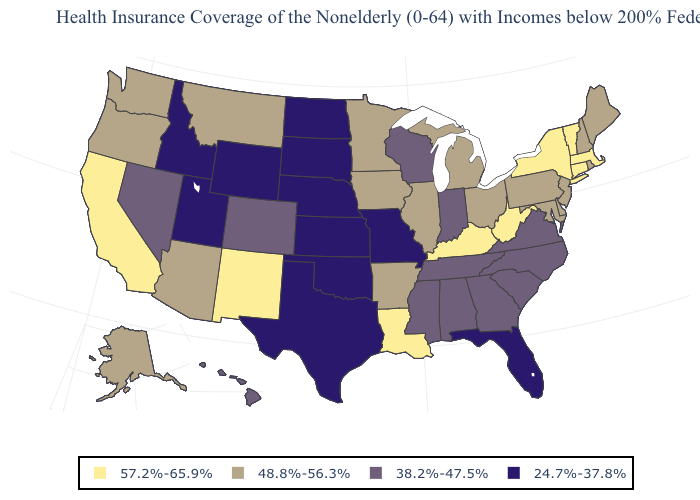Name the states that have a value in the range 24.7%-37.8%?
Write a very short answer. Florida, Idaho, Kansas, Missouri, Nebraska, North Dakota, Oklahoma, South Dakota, Texas, Utah, Wyoming. What is the value of Alaska?
Quick response, please. 48.8%-56.3%. Which states hav the highest value in the West?
Quick response, please. California, New Mexico. Does Nebraska have the same value as Virginia?
Write a very short answer. No. What is the value of Ohio?
Concise answer only. 48.8%-56.3%. Among the states that border Kentucky , does Missouri have the lowest value?
Be succinct. Yes. What is the value of South Carolina?
Write a very short answer. 38.2%-47.5%. What is the value of Nebraska?
Write a very short answer. 24.7%-37.8%. How many symbols are there in the legend?
Concise answer only. 4. What is the lowest value in the USA?
Write a very short answer. 24.7%-37.8%. Does Nevada have a lower value than Indiana?
Keep it brief. No. What is the value of Pennsylvania?
Concise answer only. 48.8%-56.3%. Name the states that have a value in the range 38.2%-47.5%?
Write a very short answer. Alabama, Colorado, Georgia, Hawaii, Indiana, Mississippi, Nevada, North Carolina, South Carolina, Tennessee, Virginia, Wisconsin. How many symbols are there in the legend?
Concise answer only. 4. Which states have the lowest value in the Northeast?
Write a very short answer. Maine, New Hampshire, New Jersey, Pennsylvania, Rhode Island. 